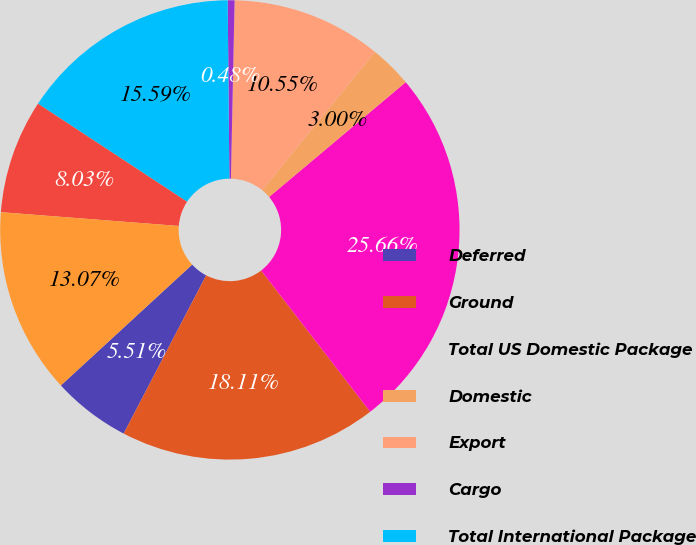Convert chart to OTSL. <chart><loc_0><loc_0><loc_500><loc_500><pie_chart><fcel>Deferred<fcel>Ground<fcel>Total US Domestic Package<fcel>Domestic<fcel>Export<fcel>Cargo<fcel>Total International Package<fcel>Forwarding Services and<fcel>Total Supply Chain & Freight<nl><fcel>5.51%<fcel>18.11%<fcel>25.66%<fcel>3.0%<fcel>10.55%<fcel>0.48%<fcel>15.59%<fcel>8.03%<fcel>13.07%<nl></chart> 